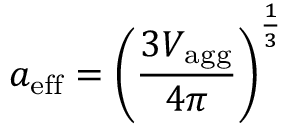<formula> <loc_0><loc_0><loc_500><loc_500>a _ { e f f } = \left ( \frac { 3 V _ { a g g } } { 4 \pi } \right ) ^ { \frac { 1 } { 3 } }</formula> 